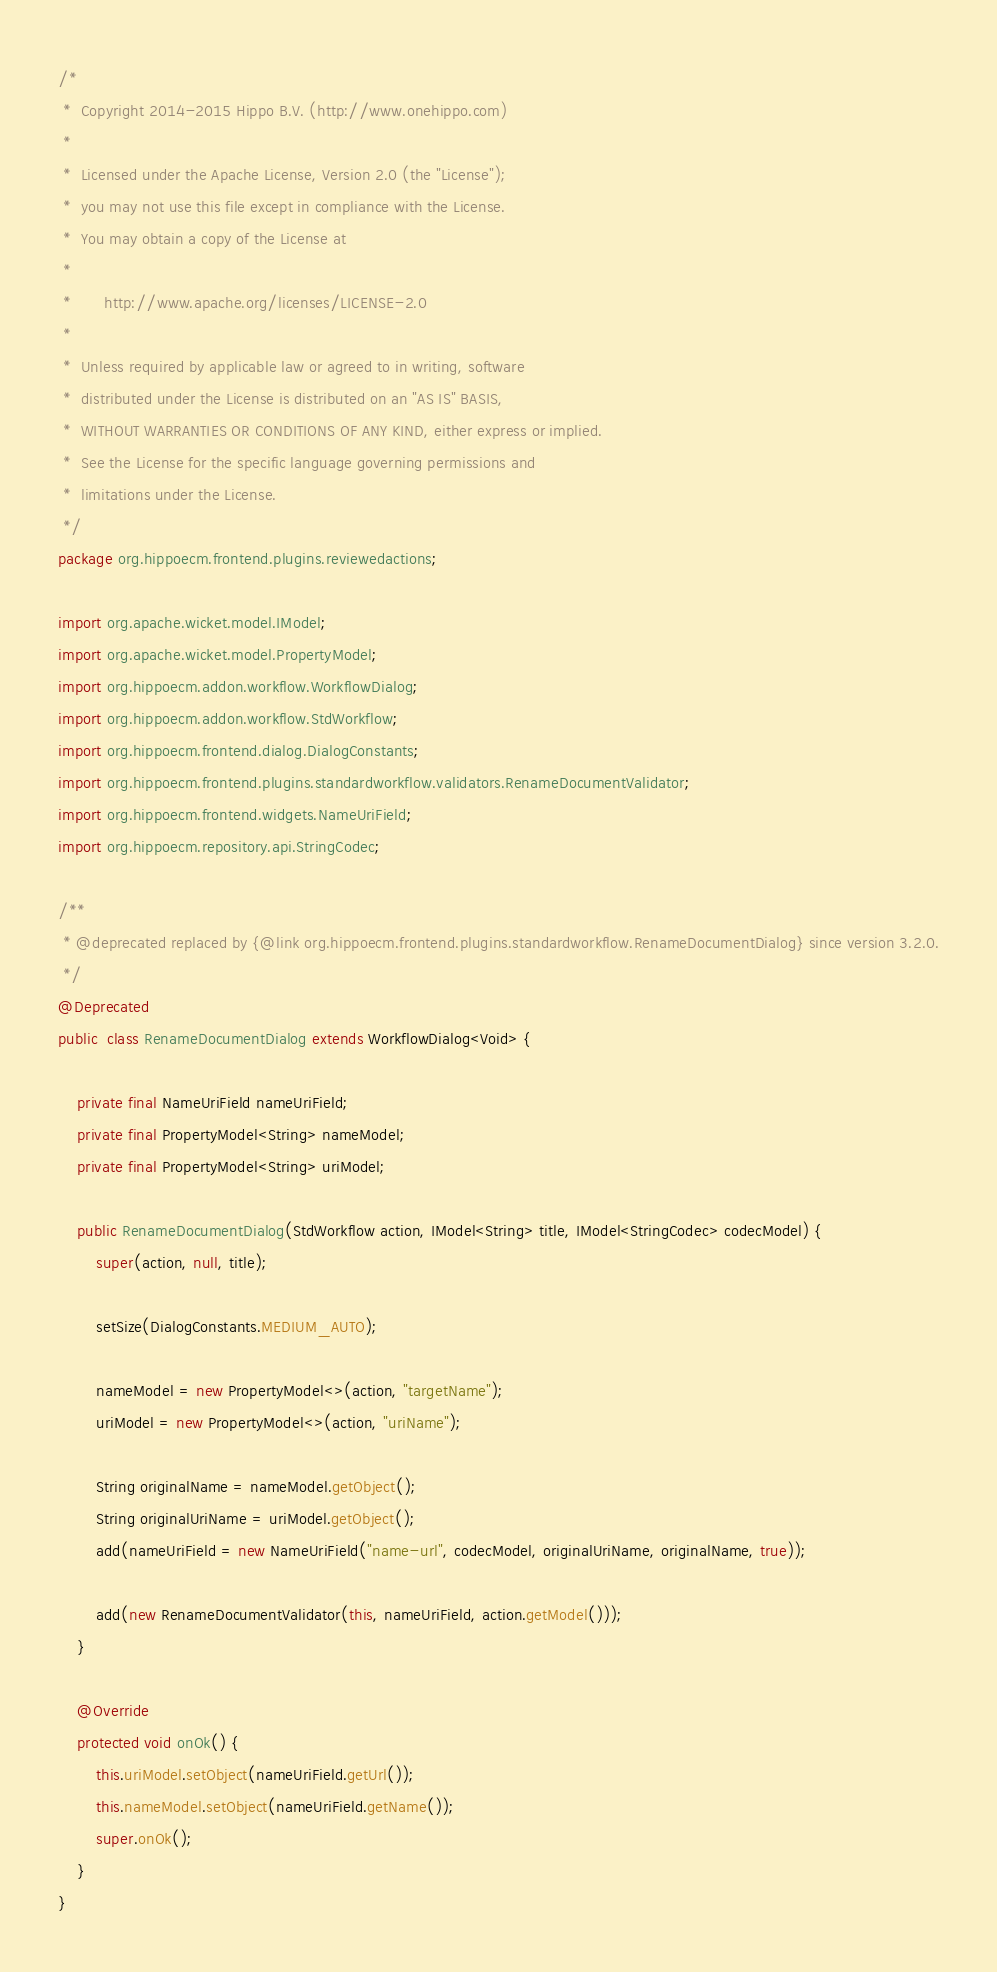Convert code to text. <code><loc_0><loc_0><loc_500><loc_500><_Java_>/*
 *  Copyright 2014-2015 Hippo B.V. (http://www.onehippo.com)
 *
 *  Licensed under the Apache License, Version 2.0 (the "License");
 *  you may not use this file except in compliance with the License.
 *  You may obtain a copy of the License at
 *
 *       http://www.apache.org/licenses/LICENSE-2.0
 *
 *  Unless required by applicable law or agreed to in writing, software
 *  distributed under the License is distributed on an "AS IS" BASIS,
 *  WITHOUT WARRANTIES OR CONDITIONS OF ANY KIND, either express or implied.
 *  See the License for the specific language governing permissions and
 *  limitations under the License.
 */
package org.hippoecm.frontend.plugins.reviewedactions;

import org.apache.wicket.model.IModel;
import org.apache.wicket.model.PropertyModel;
import org.hippoecm.addon.workflow.WorkflowDialog;
import org.hippoecm.addon.workflow.StdWorkflow;
import org.hippoecm.frontend.dialog.DialogConstants;
import org.hippoecm.frontend.plugins.standardworkflow.validators.RenameDocumentValidator;
import org.hippoecm.frontend.widgets.NameUriField;
import org.hippoecm.repository.api.StringCodec;

/**
 * @deprecated replaced by {@link org.hippoecm.frontend.plugins.standardworkflow.RenameDocumentDialog} since version 3.2.0.
 */
@Deprecated
public  class RenameDocumentDialog extends WorkflowDialog<Void> {

    private final NameUriField nameUriField;
    private final PropertyModel<String> nameModel;
    private final PropertyModel<String> uriModel;

    public RenameDocumentDialog(StdWorkflow action, IModel<String> title, IModel<StringCodec> codecModel) {
        super(action, null, title);

        setSize(DialogConstants.MEDIUM_AUTO);

        nameModel = new PropertyModel<>(action, "targetName");
        uriModel = new PropertyModel<>(action, "uriName");

        String originalName = nameModel.getObject();
        String originalUriName = uriModel.getObject();
        add(nameUriField = new NameUriField("name-url", codecModel, originalUriName, originalName, true));

        add(new RenameDocumentValidator(this, nameUriField, action.getModel()));
    }

    @Override
    protected void onOk() {
        this.uriModel.setObject(nameUriField.getUrl());
        this.nameModel.setObject(nameUriField.getName());
        super.onOk();
    }
}
</code> 